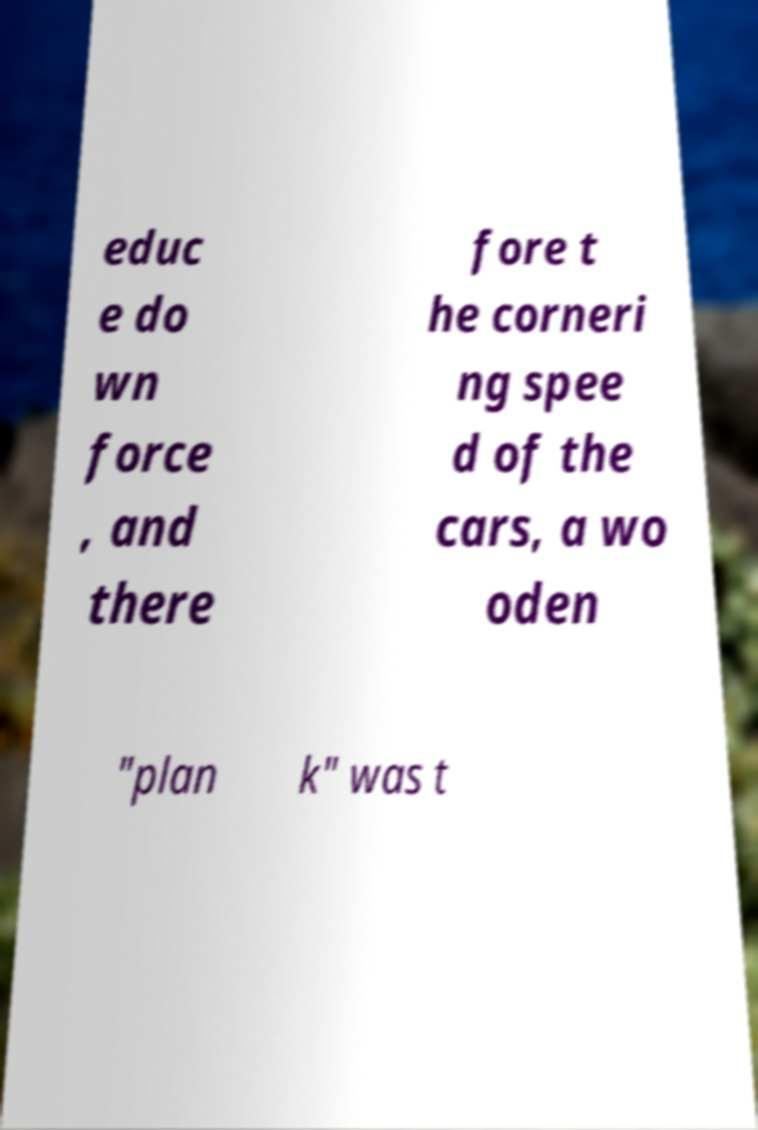Can you read and provide the text displayed in the image?This photo seems to have some interesting text. Can you extract and type it out for me? educ e do wn force , and there fore t he corneri ng spee d of the cars, a wo oden "plan k" was t 